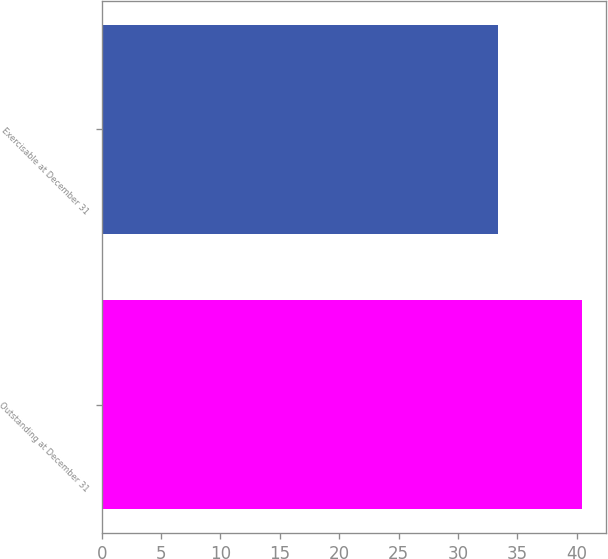Convert chart to OTSL. <chart><loc_0><loc_0><loc_500><loc_500><bar_chart><fcel>Outstanding at December 31<fcel>Exercisable at December 31<nl><fcel>40.48<fcel>33.34<nl></chart> 